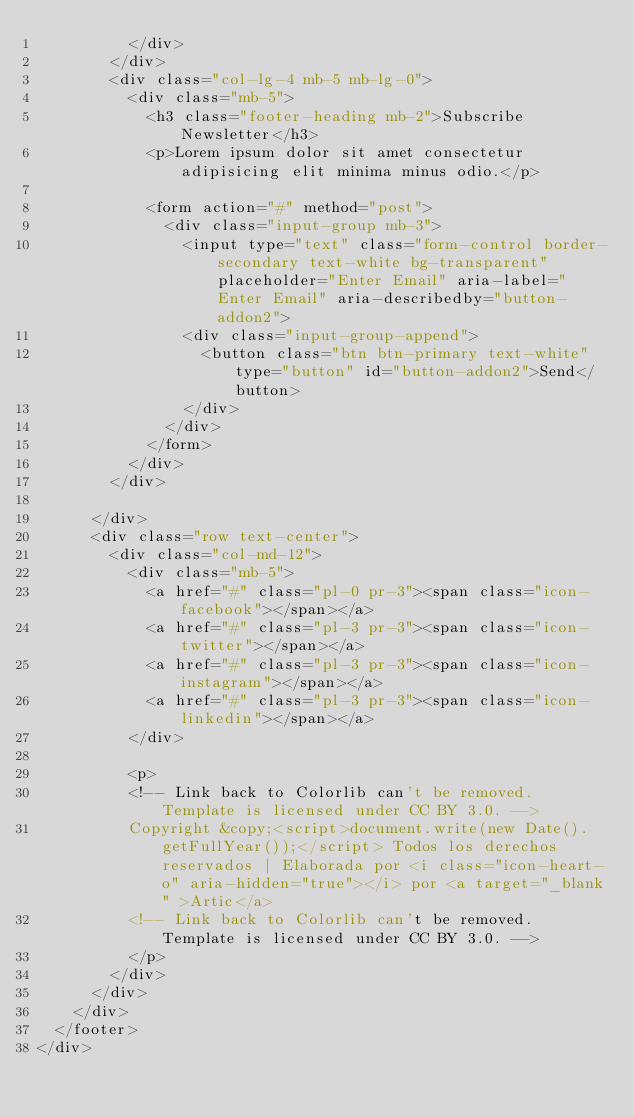Convert code to text. <code><loc_0><loc_0><loc_500><loc_500><_PHP_>          </div>
        </div>
        <div class="col-lg-4 mb-5 mb-lg-0">
          <div class="mb-5">
            <h3 class="footer-heading mb-2">Subscribe Newsletter</h3>
            <p>Lorem ipsum dolor sit amet consectetur adipisicing elit minima minus odio.</p>

            <form action="#" method="post">
              <div class="input-group mb-3">
                <input type="text" class="form-control border-secondary text-white bg-transparent" placeholder="Enter Email" aria-label="Enter Email" aria-describedby="button-addon2">
                <div class="input-group-append">
                  <button class="btn btn-primary text-white" type="button" id="button-addon2">Send</button>
                </div>
              </div>
            </form>
          </div>
        </div>
        
      </div>
      <div class="row text-center">
        <div class="col-md-12">
          <div class="mb-5">
            <a href="#" class="pl-0 pr-3"><span class="icon-facebook"></span></a>
            <a href="#" class="pl-3 pr-3"><span class="icon-twitter"></span></a>
            <a href="#" class="pl-3 pr-3"><span class="icon-instagram"></span></a>
            <a href="#" class="pl-3 pr-3"><span class="icon-linkedin"></span></a>
          </div>

          <p>
          <!-- Link back to Colorlib can't be removed. Template is licensed under CC BY 3.0. -->
          Copyright &copy;<script>document.write(new Date().getFullYear());</script> Todos los derechos reservados | Elaborada por <i class="icon-heart-o" aria-hidden="true"></i> por <a target="_blank" >Artic</a>
          <!-- Link back to Colorlib can't be removed. Template is licensed under CC BY 3.0. -->
          </p>
        </div>
      </div>
    </div>
  </footer>
</div>  
  </code> 